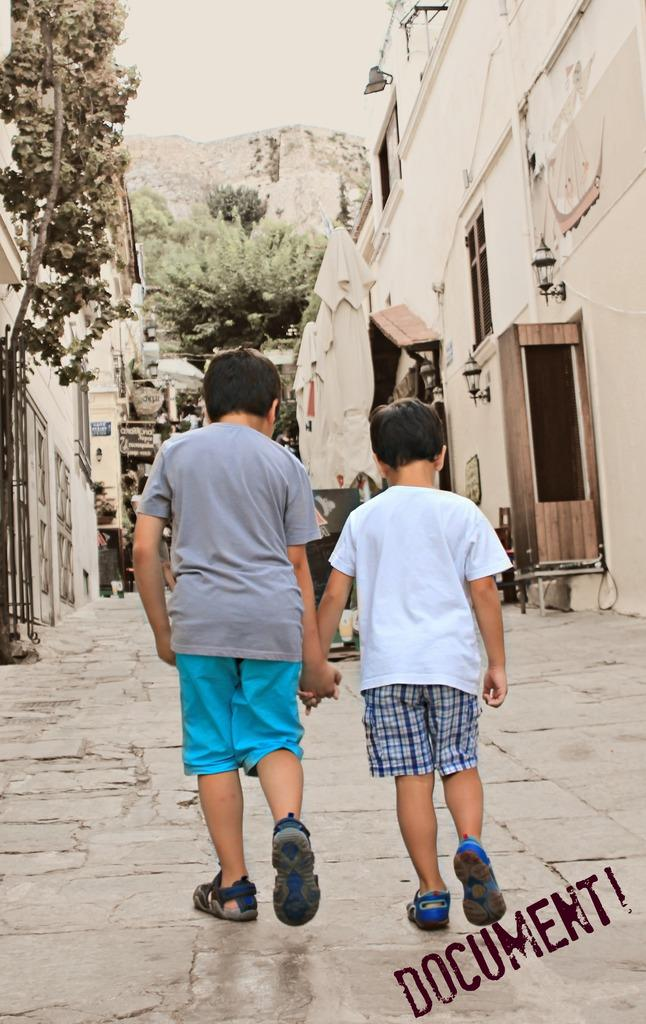How many kids are in the image? There are two kids in the image. What are the kids doing in the image? The kids are walking on a walkway. What can be seen in the background of the image? There are houses, walls, trees, lights, and a mountain in the background of the image. What is visible at the top of the image? The sky is visible at the top of the image. What type of toys are the kids playing with in the image? There are no toys visible in the image; the kids are walking on a walkway. Can you tell me the name of the woman standing next to the mountain in the image? There is no woman present in the image; it features two kids walking on a walkway and various background elements. 